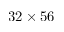Convert formula to latex. <formula><loc_0><loc_0><loc_500><loc_500>3 2 \times 5 6</formula> 